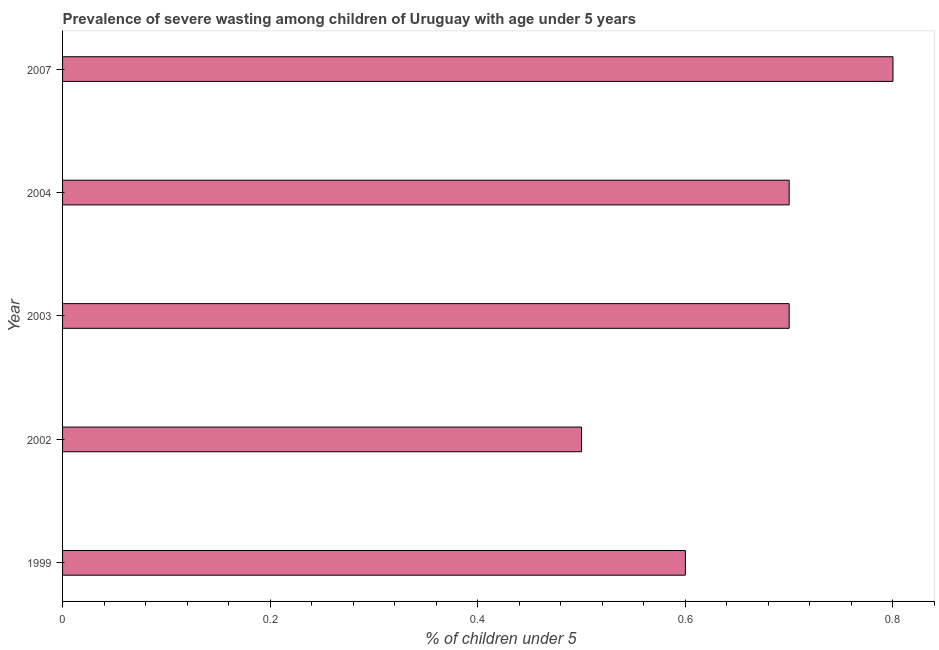Does the graph contain any zero values?
Your answer should be very brief. No. What is the title of the graph?
Provide a succinct answer. Prevalence of severe wasting among children of Uruguay with age under 5 years. What is the label or title of the X-axis?
Offer a very short reply.  % of children under 5. What is the label or title of the Y-axis?
Your answer should be compact. Year. What is the prevalence of severe wasting in 2003?
Ensure brevity in your answer.  0.7. Across all years, what is the maximum prevalence of severe wasting?
Offer a terse response. 0.8. In which year was the prevalence of severe wasting maximum?
Keep it short and to the point. 2007. In which year was the prevalence of severe wasting minimum?
Make the answer very short. 2002. What is the sum of the prevalence of severe wasting?
Ensure brevity in your answer.  3.3. What is the average prevalence of severe wasting per year?
Keep it short and to the point. 0.66. What is the median prevalence of severe wasting?
Ensure brevity in your answer.  0.7. In how many years, is the prevalence of severe wasting greater than 0.24 %?
Give a very brief answer. 5. Do a majority of the years between 2002 and 2003 (inclusive) have prevalence of severe wasting greater than 0.2 %?
Provide a succinct answer. Yes. Is the difference between the prevalence of severe wasting in 1999 and 2003 greater than the difference between any two years?
Your answer should be compact. No. What is the difference between the highest and the lowest prevalence of severe wasting?
Ensure brevity in your answer.  0.3. In how many years, is the prevalence of severe wasting greater than the average prevalence of severe wasting taken over all years?
Ensure brevity in your answer.  3. What is the difference between two consecutive major ticks on the X-axis?
Provide a short and direct response. 0.2. Are the values on the major ticks of X-axis written in scientific E-notation?
Make the answer very short. No. What is the  % of children under 5 of 1999?
Provide a short and direct response. 0.6. What is the  % of children under 5 of 2002?
Make the answer very short. 0.5. What is the  % of children under 5 in 2003?
Ensure brevity in your answer.  0.7. What is the  % of children under 5 in 2004?
Your answer should be compact. 0.7. What is the  % of children under 5 of 2007?
Offer a very short reply. 0.8. What is the difference between the  % of children under 5 in 1999 and 2003?
Provide a short and direct response. -0.1. What is the difference between the  % of children under 5 in 1999 and 2004?
Your response must be concise. -0.1. What is the difference between the  % of children under 5 in 2002 and 2004?
Ensure brevity in your answer.  -0.2. What is the difference between the  % of children under 5 in 2002 and 2007?
Your response must be concise. -0.3. What is the ratio of the  % of children under 5 in 1999 to that in 2002?
Offer a very short reply. 1.2. What is the ratio of the  % of children under 5 in 1999 to that in 2003?
Give a very brief answer. 0.86. What is the ratio of the  % of children under 5 in 1999 to that in 2004?
Ensure brevity in your answer.  0.86. What is the ratio of the  % of children under 5 in 2002 to that in 2003?
Make the answer very short. 0.71. What is the ratio of the  % of children under 5 in 2002 to that in 2004?
Provide a succinct answer. 0.71. What is the ratio of the  % of children under 5 in 2002 to that in 2007?
Offer a very short reply. 0.62. What is the ratio of the  % of children under 5 in 2003 to that in 2007?
Your answer should be very brief. 0.88. What is the ratio of the  % of children under 5 in 2004 to that in 2007?
Give a very brief answer. 0.88. 